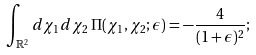Convert formula to latex. <formula><loc_0><loc_0><loc_500><loc_500>\int _ { \mathbb { R } ^ { 2 } } d \chi _ { 1 } d \chi _ { 2 } \, \Pi ( \chi _ { 1 } , \chi _ { 2 } ; \epsilon ) = - \frac { 4 } { ( 1 + \epsilon ) ^ { 2 } } ;</formula> 